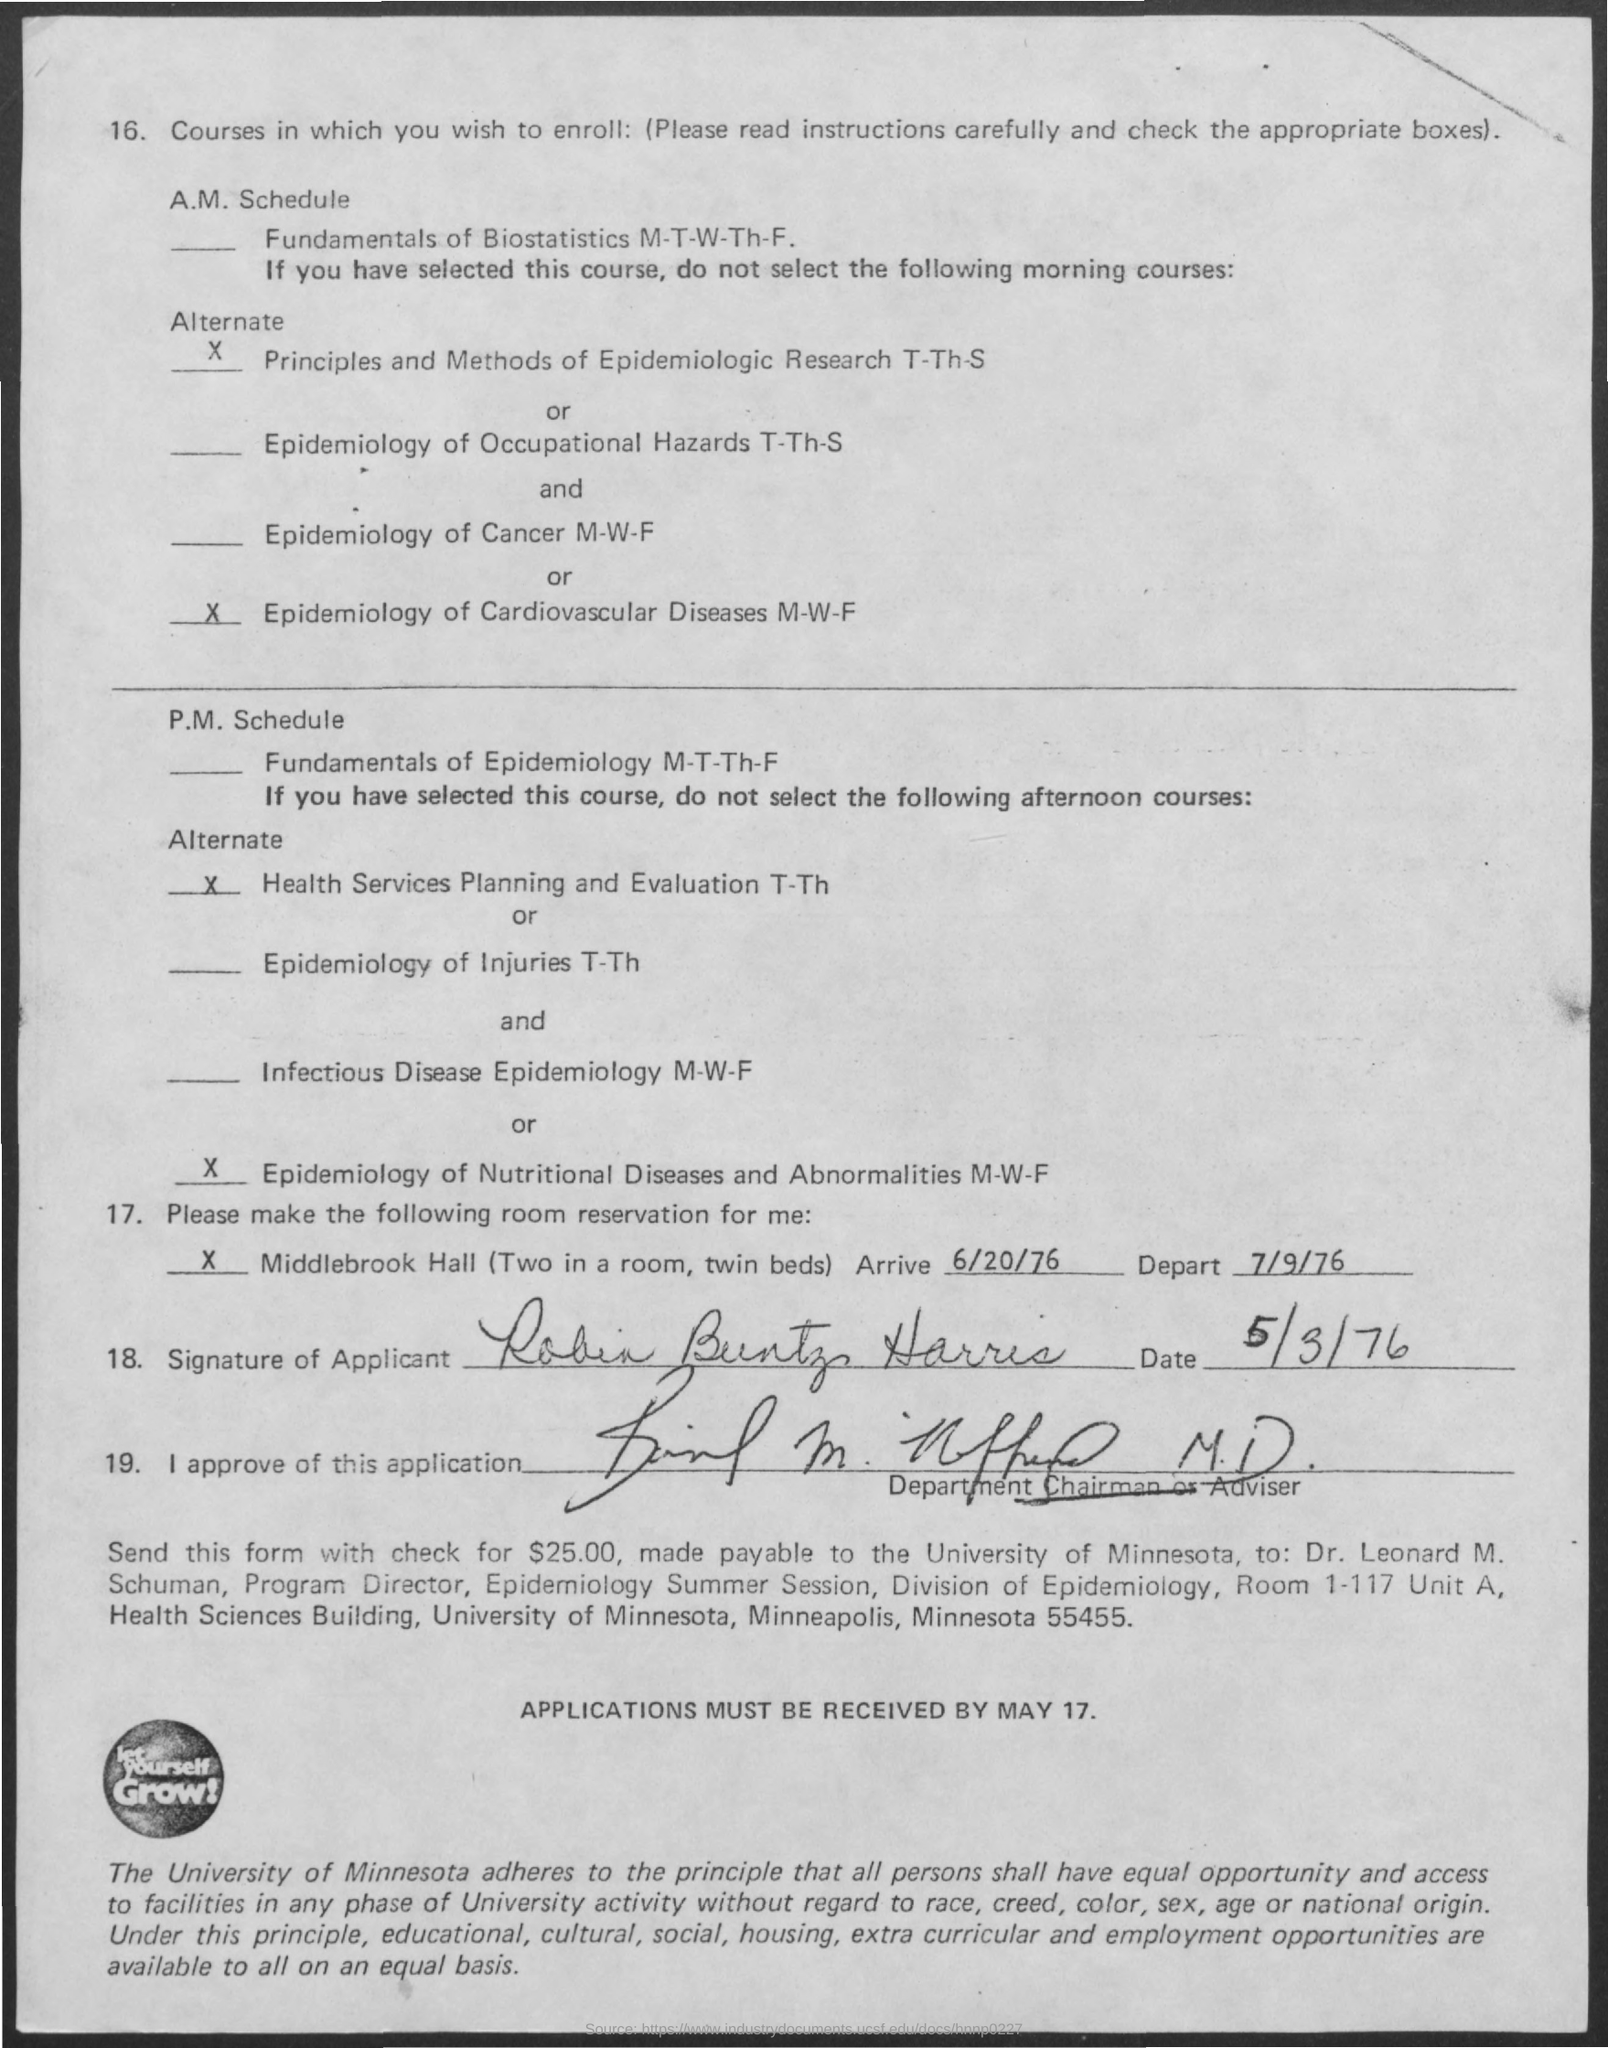When is the "Arrive" date?
Ensure brevity in your answer.  6/20/76. When is the "Depart" date?
Offer a very short reply. 7/9/76. 